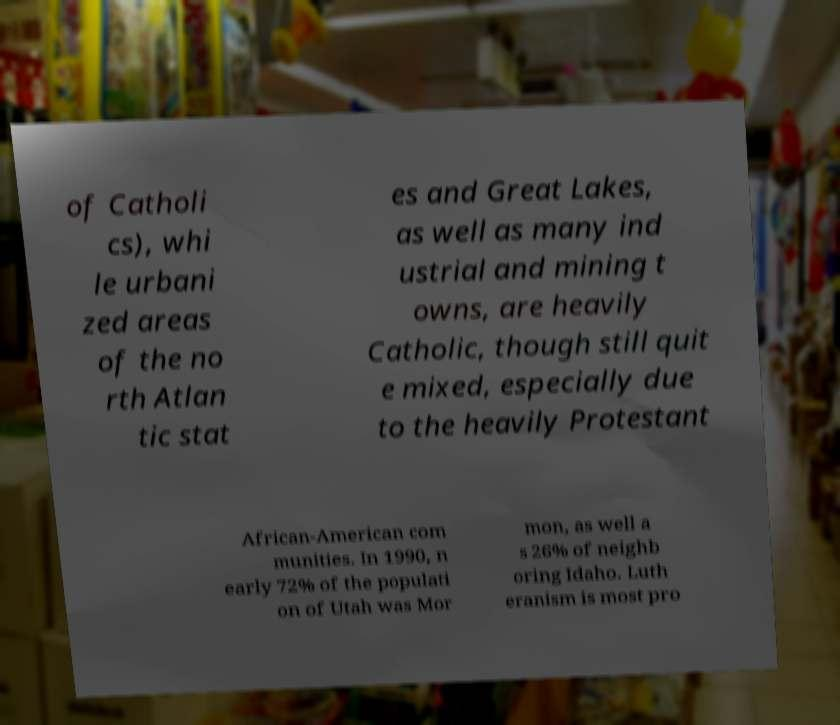Please identify and transcribe the text found in this image. of Catholi cs), whi le urbani zed areas of the no rth Atlan tic stat es and Great Lakes, as well as many ind ustrial and mining t owns, are heavily Catholic, though still quit e mixed, especially due to the heavily Protestant African-American com munities. In 1990, n early 72% of the populati on of Utah was Mor mon, as well a s 26% of neighb oring Idaho. Luth eranism is most pro 